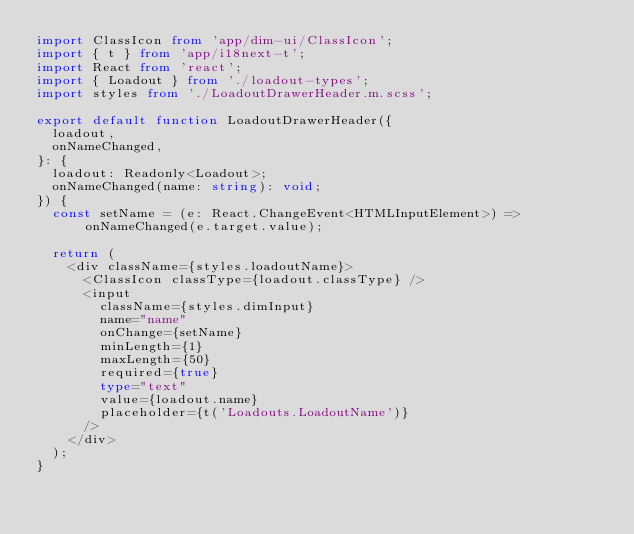Convert code to text. <code><loc_0><loc_0><loc_500><loc_500><_TypeScript_>import ClassIcon from 'app/dim-ui/ClassIcon';
import { t } from 'app/i18next-t';
import React from 'react';
import { Loadout } from './loadout-types';
import styles from './LoadoutDrawerHeader.m.scss';

export default function LoadoutDrawerHeader({
  loadout,
  onNameChanged,
}: {
  loadout: Readonly<Loadout>;
  onNameChanged(name: string): void;
}) {
  const setName = (e: React.ChangeEvent<HTMLInputElement>) => onNameChanged(e.target.value);

  return (
    <div className={styles.loadoutName}>
      <ClassIcon classType={loadout.classType} />
      <input
        className={styles.dimInput}
        name="name"
        onChange={setName}
        minLength={1}
        maxLength={50}
        required={true}
        type="text"
        value={loadout.name}
        placeholder={t('Loadouts.LoadoutName')}
      />
    </div>
  );
}
</code> 